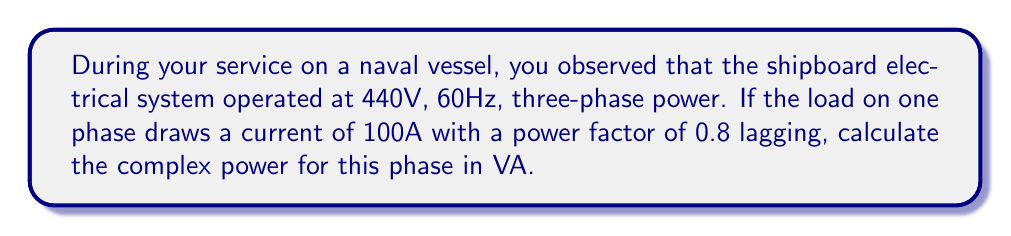Can you answer this question? Let's approach this step-by-step:

1) In a three-phase system, we can calculate the complex power for one phase and then multiply by 3 for the total system power. We'll focus on one phase for this problem.

2) The complex power $S$ is given by the equation:

   $$S = V I^*$$

   where $V$ is the complex voltage, $I^*$ is the complex conjugate of the current, and $S$ is in VA (Volt-Amperes).

3) We're given the RMS voltage (440V) and current (100A), but this is the line-to-line voltage. For a single phase, we need the phase voltage, which is:

   $$V_{phase} = \frac{V_{line}}{\sqrt{3}} = \frac{440}{\sqrt{3}} \approx 254.03 V$$

4) The power factor (pf) of 0.8 lagging tells us the phase angle between voltage and current. We can calculate this angle:

   $$\theta = \cos^{-1}(0.8) \approx 36.87°$$

5) Now we can express the voltage and current as complex numbers:

   $$V = 254.03 \angle 0° = 254.03 + 0j$$
   $$I = 100 \angle -36.87° = 80 - 60j$$

   Note that the current lags the voltage, hence the negative angle.

6) To calculate $S$, we multiply $V$ by the complex conjugate of $I$:

   $$S = (254.03 + 0j)(80 + 60j)$$

7) Multiplying these complex numbers:

   $$S = 20322.4 + 15241.8j$$

8) This can be expressed in polar form:

   $$S = 25403 \angle 36.87° VA$$

The real part (20322.4) represents the active power (P) in watts, and the imaginary part (15241.8) represents the reactive power (Q) in vars.
Answer: $S = 20322.4 + 15241.8j$ VA or $25403 \angle 36.87°$ VA 